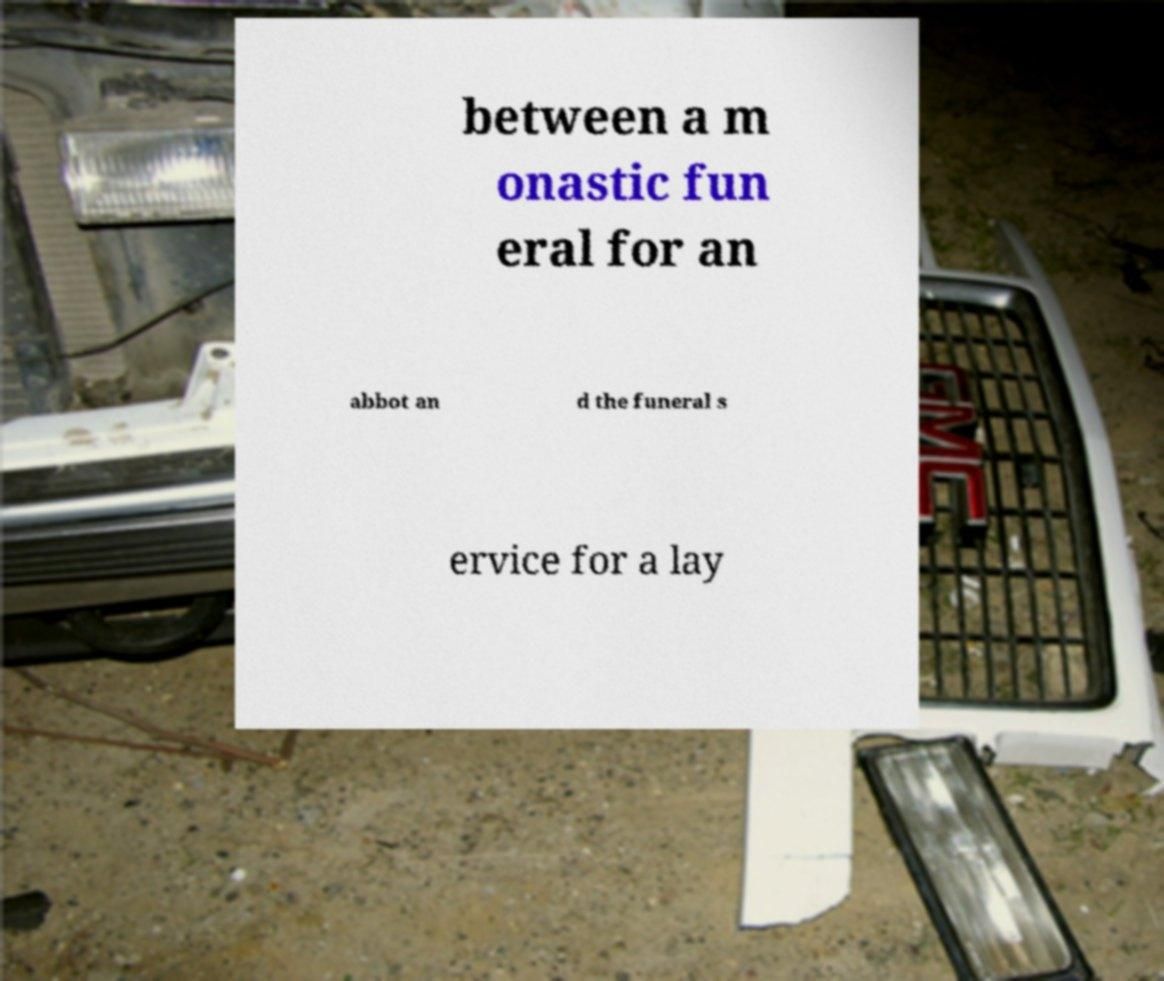Can you accurately transcribe the text from the provided image for me? between a m onastic fun eral for an abbot an d the funeral s ervice for a lay 